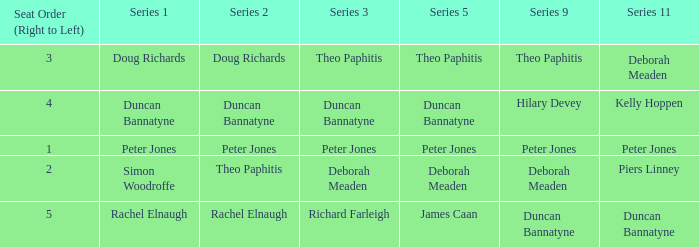Which series 2 includes a series 3 with deborah meaden? Theo Paphitis. 